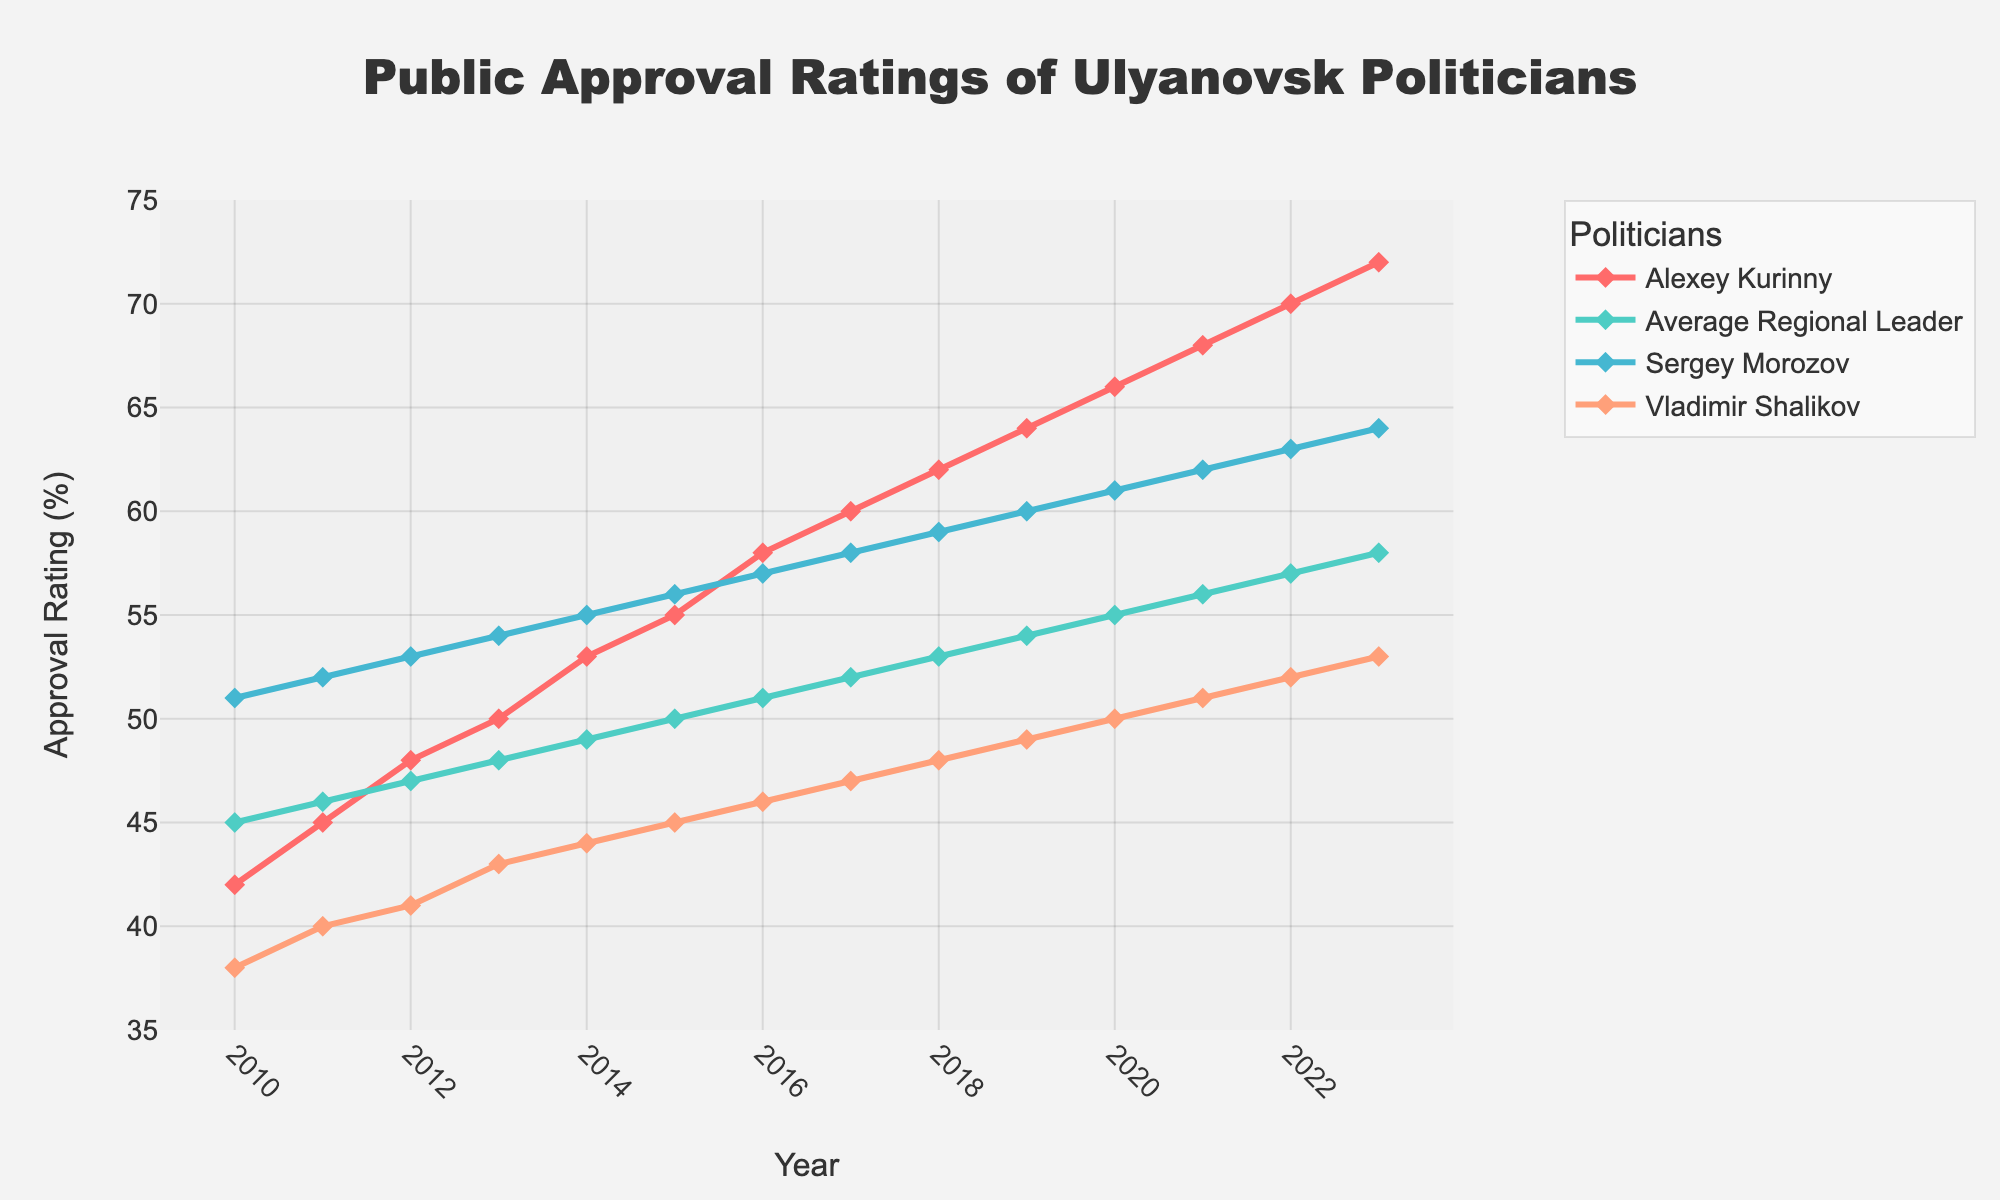What's the highest approval rating Alexey Kurinny achieved, and in what year? According to the figure, Kurinny's highest approval rating was achieved in 2023 at 72%.
Answer: 2023, 72% In which year did Alexey Kurinny's approval rating surpass the average regional leader's approval rating? The approval ratings for Kurinny and the average regional leader intersect in 2013. After that year, Kurinny's approval rating is always higher.
Answer: 2013 How does Alexey Kurinny's approval rating in 2018 compare to Sergey Morozov's in the same year? In 2018, Alexey Kurinny's approval rating was 62%, whereas Sergey Morozov's was 59%. Kurinny's rating is higher by 3%.
Answer: 3% Between 2015 and 2020, by how many points did Vladimir Shalikov's approval rating increase? Vladimir Shalikov's approval rating in 2015 was 45%, and in 2020, it was 50%. The increase is 50% - 45% = 5%.
Answer: 5% Calculate the average approval rating of Sergey Morozov over the given years. Summing up the approval ratings of Sergey Morozov from 2010 to 2023: 51 + 52 + 53 + 54 + 55 + 56 + 57 + 58 + 59 + 60 + 61 + 62 + 63 + 64 = 819. Dividing by the number of years (14): 819 / 14 ≈ 58.5.
Answer: 58.5 Which politician had the lowest approval rating in 2021? In 2021, the approval ratings were Kurinny: 68%, Average Leader: 56%, Morozov: 62%, Shalikov: 51%. The lowest rating is Vladimir Shalikov's at 51%.
Answer: Shalikov Did Alexey Kurinny's approval rating ever decrease? If so, mention the year and the amount. Alexey Kurinny's approval rating shows a consistent increase every year, as no decreases are observed from 2010 to 2023.
Answer: No Determine the approval rating trend for the average regional leader from 2010 to 2023. The figure indicates a continuous upward trend, starting at 45% in 2010 and reaching 58% in 2023.
Answer: Upward What is the difference in approval ratings between Alexey Kurinny and the average regional leader in 2023? In 2023, Alexey Kurinny's approval rating is 72%, and the average regional leader's rating is 58%. The difference is 72% - 58% = 14%.
Answer: 14% Which year shows the highest difference in approval ratings between Alexey Kurinny and Vladimir Shalikov? In 2023, Kurinny has a rating of 72%, and Shalikov has 53%, making the difference 72% - 53% = 19%.
Answer: 2023, 19% 